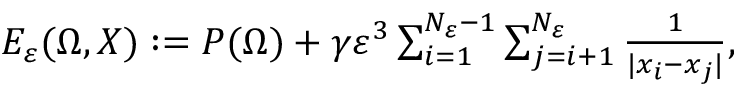Convert formula to latex. <formula><loc_0><loc_0><loc_500><loc_500>\begin{array} { r } { E _ { \varepsilon } ( \Omega , X ) \colon = P ( \Omega ) + \gamma \varepsilon ^ { 3 } \sum _ { i = 1 } ^ { N _ { \varepsilon } - 1 } \sum _ { j = i + 1 } ^ { N _ { \varepsilon } } { \frac { 1 } { | x _ { i } - x _ { j } | } } , } \end{array}</formula> 